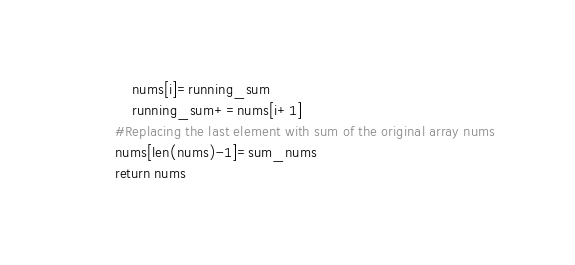<code> <loc_0><loc_0><loc_500><loc_500><_Python_>            nums[i]=running_sum
            running_sum+=nums[i+1]
        #Replacing the last element with sum of the original array nums
        nums[len(nums)-1]=sum_nums
        return nums

</code> 